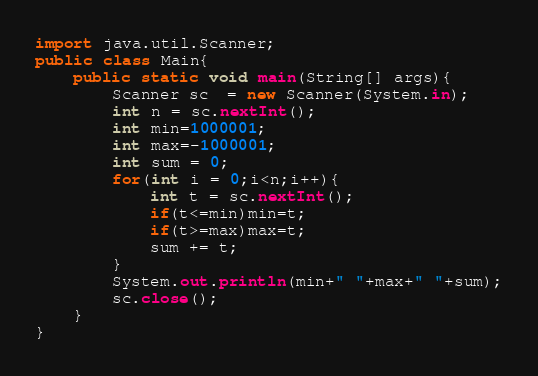Convert code to text. <code><loc_0><loc_0><loc_500><loc_500><_Java_>import java.util.Scanner;
public class Main{
    public static void main(String[] args){
        Scanner sc  = new Scanner(System.in);
        int n = sc.nextInt();
        int min=1000001;
        int max=-1000001;
        int sum = 0;
        for(int i = 0;i<n;i++){
            int t = sc.nextInt();
            if(t<=min)min=t;
            if(t>=max)max=t;
            sum += t;
        }
        System.out.println(min+" "+max+" "+sum);
        sc.close();
    }
}

</code> 